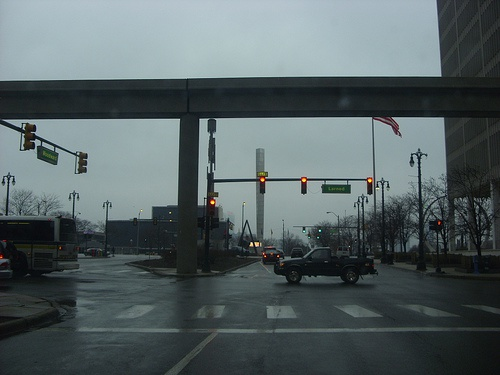Describe the objects in this image and their specific colors. I can see bus in darkgray, black, gray, and purple tones, truck in darkgray, black, gray, purple, and darkblue tones, traffic light in darkgray, black, and gray tones, car in darkgray, black, purple, maroon, and brown tones, and car in darkgray, black, gray, and blue tones in this image. 